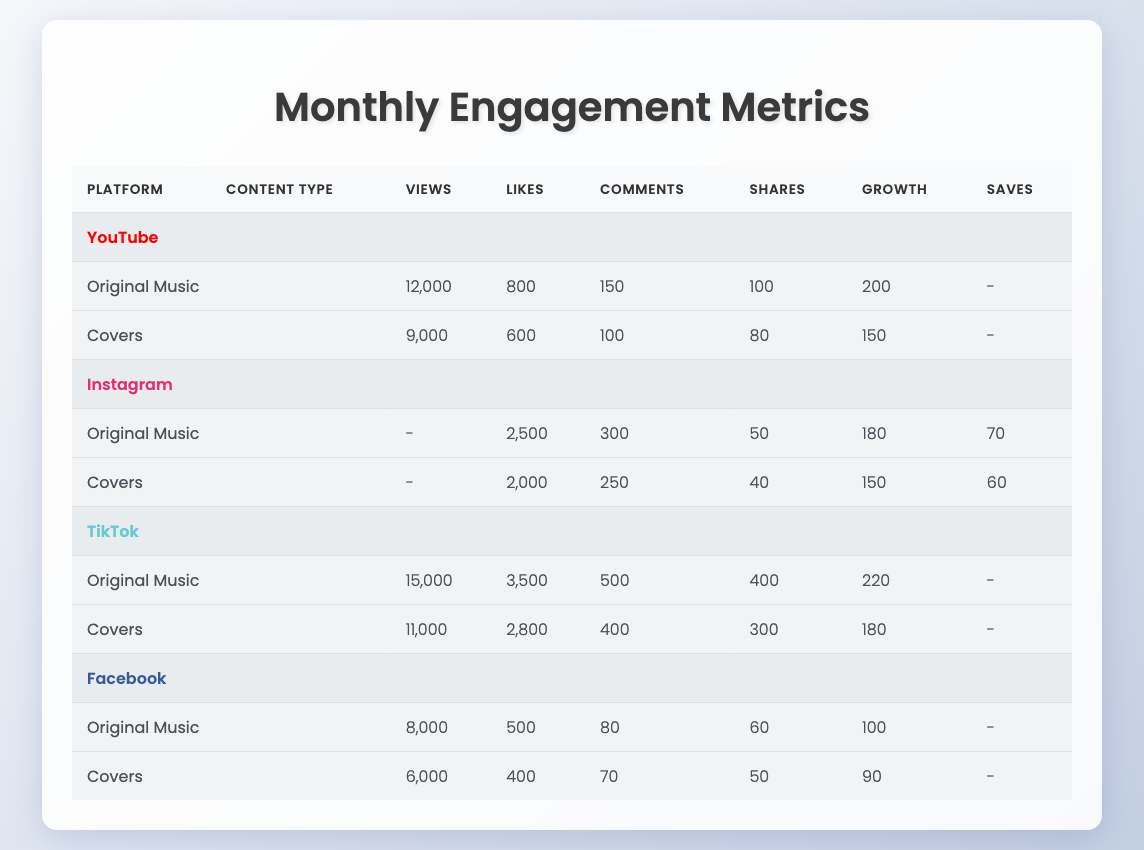What is the total monthly views for original music on YouTube? The monthly views for original music on YouTube is given directly in the table as 12,000. Therefore, the total monthly views for original music on YouTube is 12,000.
Answer: 12,000 How many monthly likes does TikTok receive for its original music? The table indicates that TikTok has 3,500 monthly likes for original music. This value is taken directly from the corresponding row for TikTok and original music.
Answer: 3,500 Which platform has the highest number of monthly comments for original music? By comparing the monthly comments for original music across all platforms, the values are: YouTube (150), Instagram (300), TikTok (500), and Facebook (80). TikTok has the highest number with 500 comments.
Answer: TikTok What is the difference in monthly shares between original music and covers on Instagram? The monthly shares for original music on Instagram is 50, while for covers it is 40. The difference is calculated as 50 - 40 = 10.
Answer: 10 Does Facebook have more monthly views for original music than for covers? On Facebook, the monthly views for original music are 8,000, and for covers, they are 6,000. Since 8,000 is greater than 6,000, the statement is true.
Answer: Yes Which platform has the least monthly growth in subscribers for original music? The monthly growth in subscribers for original music is as follows: YouTube (200), Instagram (180), TikTok (220), and Facebook (100). Facebook has the least monthly growth at 100.
Answer: Facebook What is the average number of monthly likes for original music across all platforms? The monthly likes for original music on each platform are: YouTube (800), Instagram (2,500), TikTok (3,500), and Facebook (500). The average is calculated by summing these values (800 + 2500 + 3500 + 500 = 7300) and dividing by the number of platforms (7300 / 4 = 1825).
Answer: 1,825 On which platform do covers receive the highest number of monthly views? The monthly views for covers on each platform are as follows: YouTube (9,000), Instagram (2,000), TikTok (11,000), and Facebook (6,000). TikTok has the highest number of monthly views for covers at 11,000.
Answer: TikTok How does the monthly engagement metrics for original music on Instagram compare to that of YouTube? Comparing the metrics, YouTube has 12,000 views, 800 likes, 150 comments, and 100 shares for original music, while Instagram has 0 views (not applicable), 2,500 likes, 300 comments, 50 shares, and 180 growth. In terms of likes, comments, and shares, Instagram exceeds YouTube, but YouTube has significantly higher views.
Answer: YouTube has higher views; Instagram has higher likes and comments 